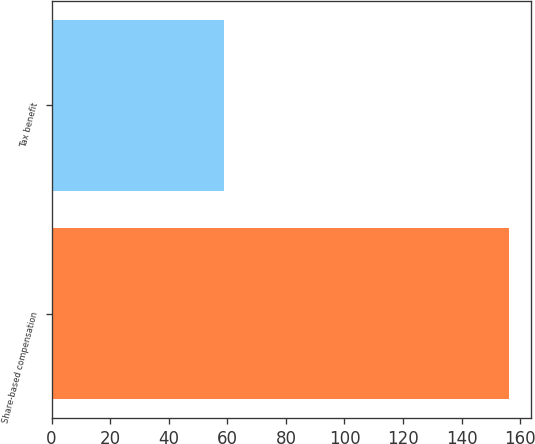<chart> <loc_0><loc_0><loc_500><loc_500><bar_chart><fcel>Share-based compensation<fcel>Tax benefit<nl><fcel>156<fcel>59<nl></chart> 